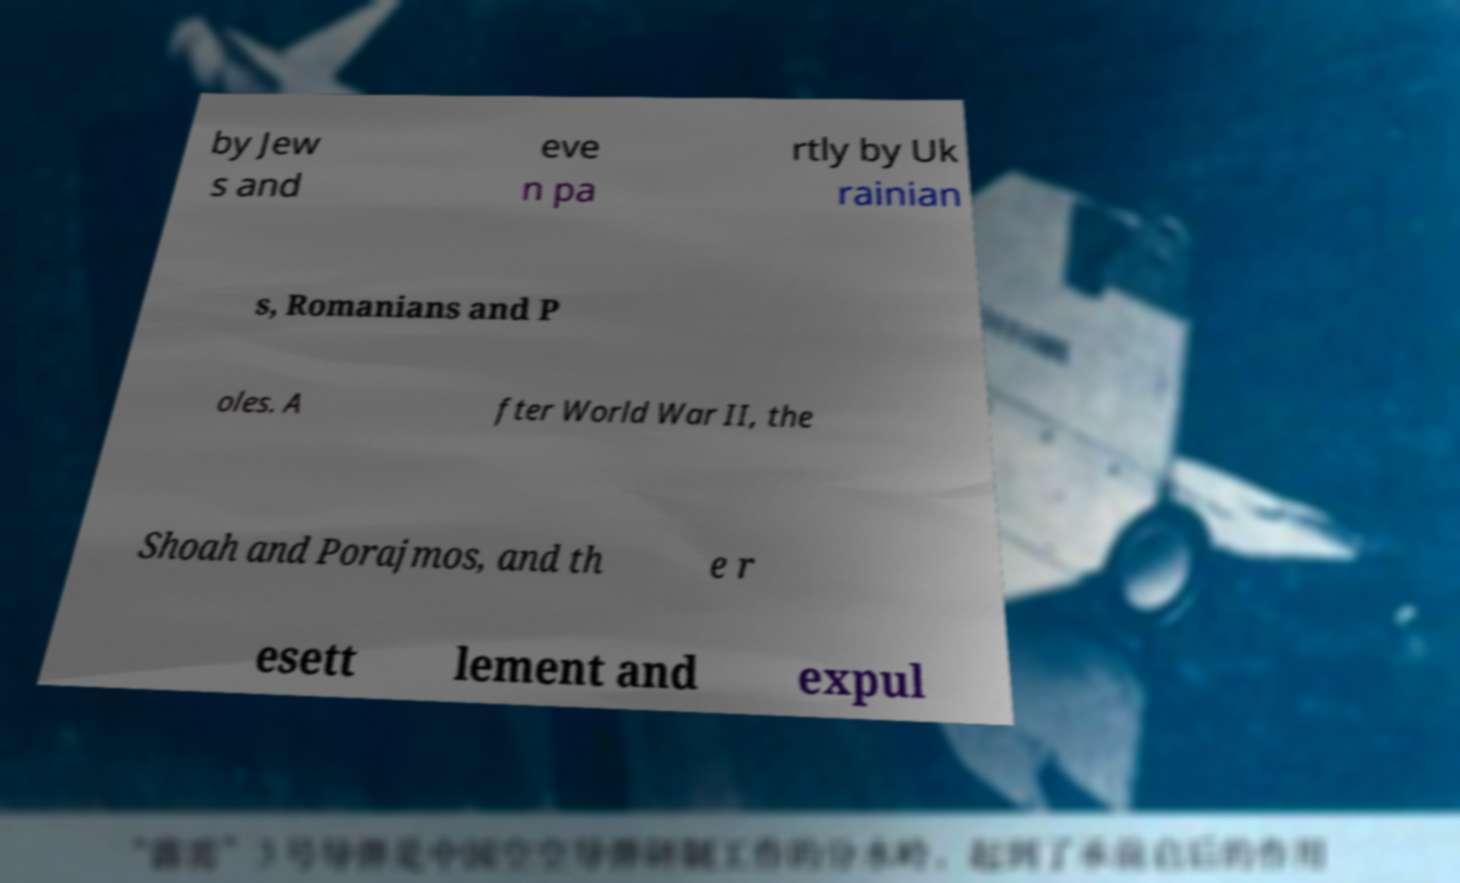Could you extract and type out the text from this image? by Jew s and eve n pa rtly by Uk rainian s, Romanians and P oles. A fter World War II, the Shoah and Porajmos, and th e r esett lement and expul 